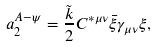Convert formula to latex. <formula><loc_0><loc_0><loc_500><loc_500>a _ { 2 } ^ { A - \psi } = \frac { \tilde { k } } { 2 } C ^ { \ast \mu \nu } \bar { \xi } \gamma _ { \mu \nu } \xi ,</formula> 